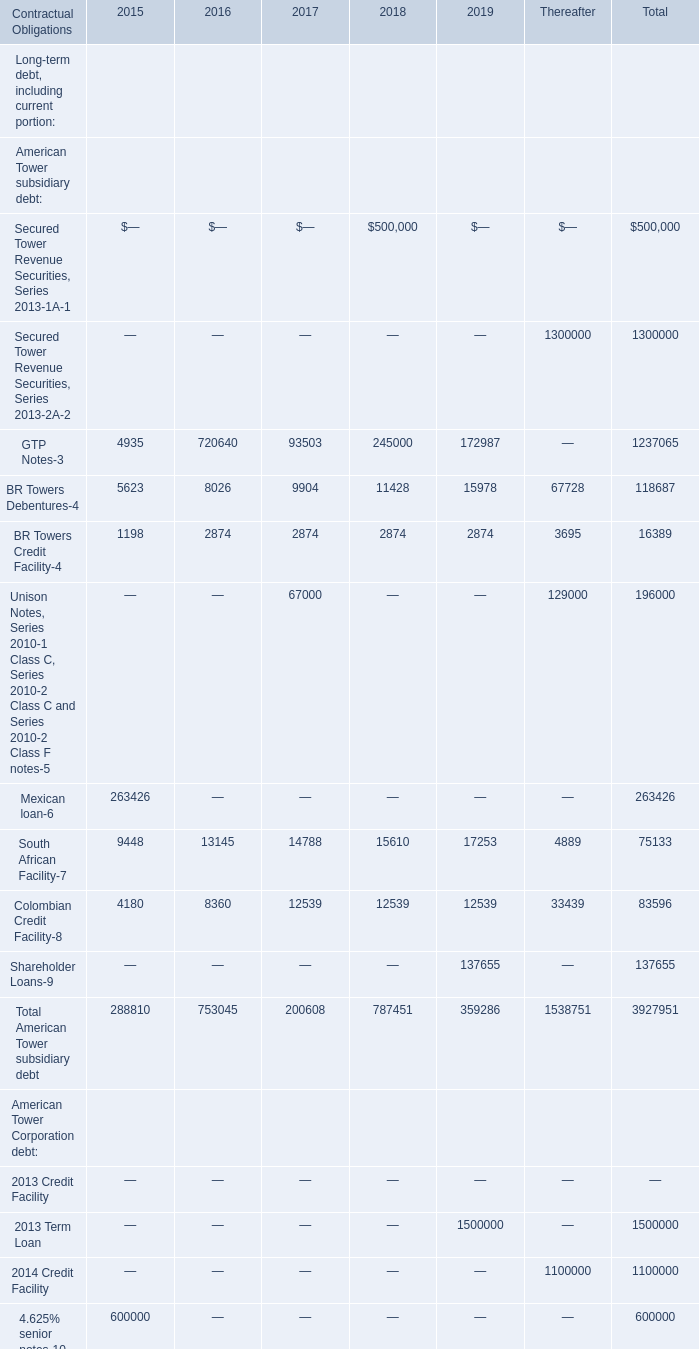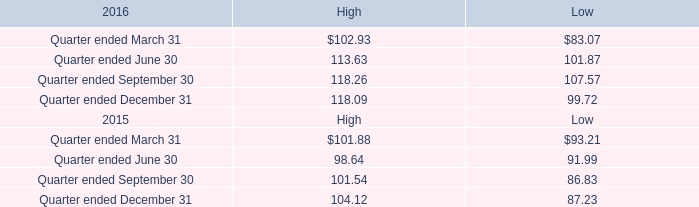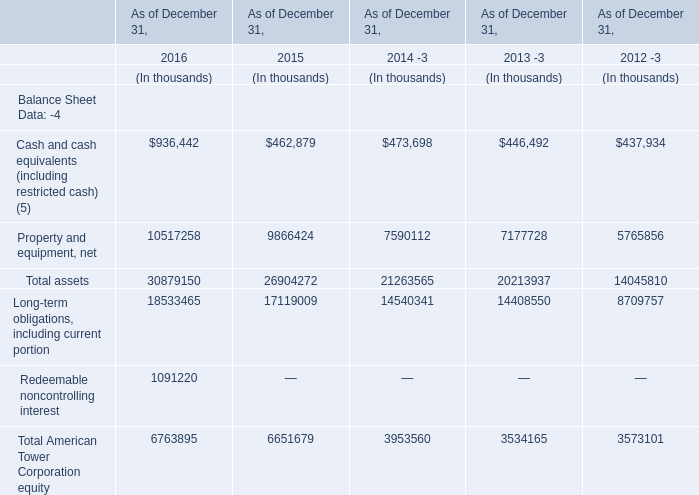Between 2017 and 2018, which year is Total American Tower subsidiary debt the lowest ? 
Answer: 2017. 